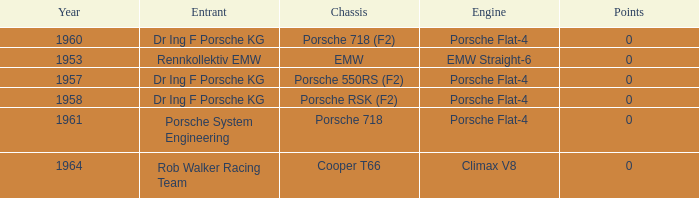What chassis did the porsche flat-4 use before 1958? Porsche 550RS (F2). 